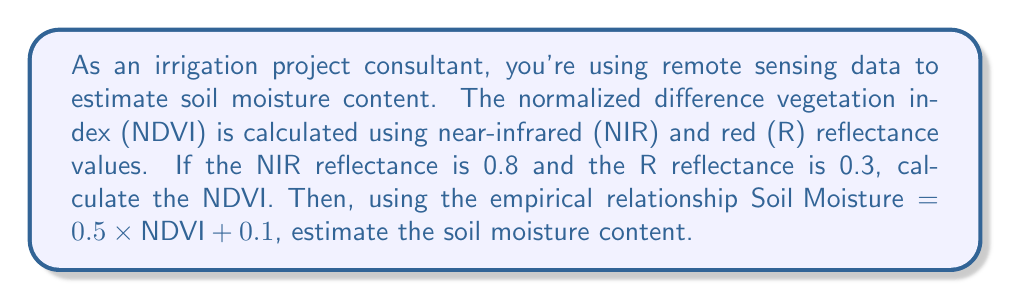Help me with this question. 1. Calculate NDVI:
   The formula for NDVI is:
   $$\text{NDVI} = \frac{\text{NIR} - \text{R}}{\text{NIR} + \text{R}}$$

   Substituting the given values:
   $$\text{NDVI} = \frac{0.8 - 0.3}{0.8 + 0.3} = \frac{0.5}{1.1} \approx 0.4545$$

2. Estimate soil moisture content:
   Using the given empirical relationship:
   $$\text{Soil Moisture} = 0.5 \times \text{NDVI} + 0.1$$

   Substituting the calculated NDVI:
   $$\text{Soil Moisture} = 0.5 \times 0.4545 + 0.1 \approx 0.3273$$

Therefore, the estimated soil moisture content is approximately 0.3273 or 32.73%.
Answer: 0.3273 